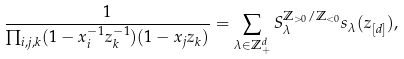Convert formula to latex. <formula><loc_0><loc_0><loc_500><loc_500>\frac { 1 } { \prod _ { i , j , k } ( 1 - x _ { i } ^ { - 1 } z _ { k } ^ { - 1 } ) ( 1 - x _ { j } z _ { k } ) } = \sum _ { \lambda \in \mathbb { Z } _ { + } ^ { d } } S _ { \lambda } ^ { \mathbb { Z } _ { > 0 } / \mathbb { Z } _ { < 0 } } s _ { \lambda } ( { z } _ { [ d ] } ) ,</formula> 